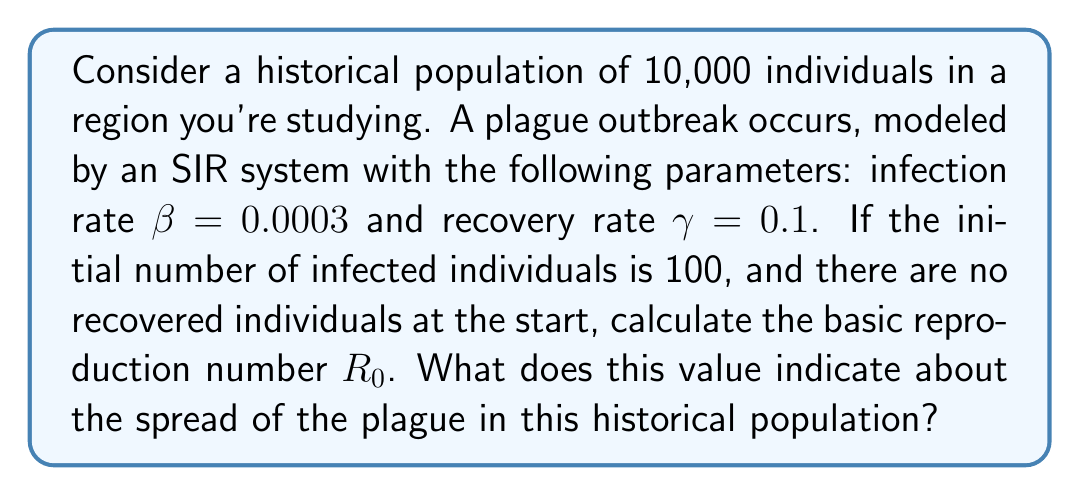Give your solution to this math problem. To solve this problem, we'll follow these steps:

1) The basic reproduction number $R_0$ in an SIR model is given by the formula:

   $$R_0 = \frac{\beta N}{\gamma}$$

   where:
   $\beta$ is the infection rate
   $N$ is the total population
   $\gamma$ is the recovery rate

2) We're given:
   $\beta = 0.0003$
   $N = 10,000$
   $\gamma = 0.1$

3) Let's substitute these values into the formula:

   $$R_0 = \frac{0.0003 \times 10,000}{0.1}$$

4) Simplify:
   $$R_0 = \frac{3}{0.1} = 30$$

5) Interpret the result:
   - If $R_0 > 1$, the disease will spread and there will be an epidemic.
   - If $R_0 < 1$, the disease will die out.

   In this case, $R_0 = 30$, which is significantly greater than 1.

6) This high $R_0$ value indicates that, on average, each infected person will infect 30 others during their infectious period, suggesting a rapid and widespread plague outbreak in this historical population.
Answer: $R_0 = 30$; indicates a severe epidemic. 